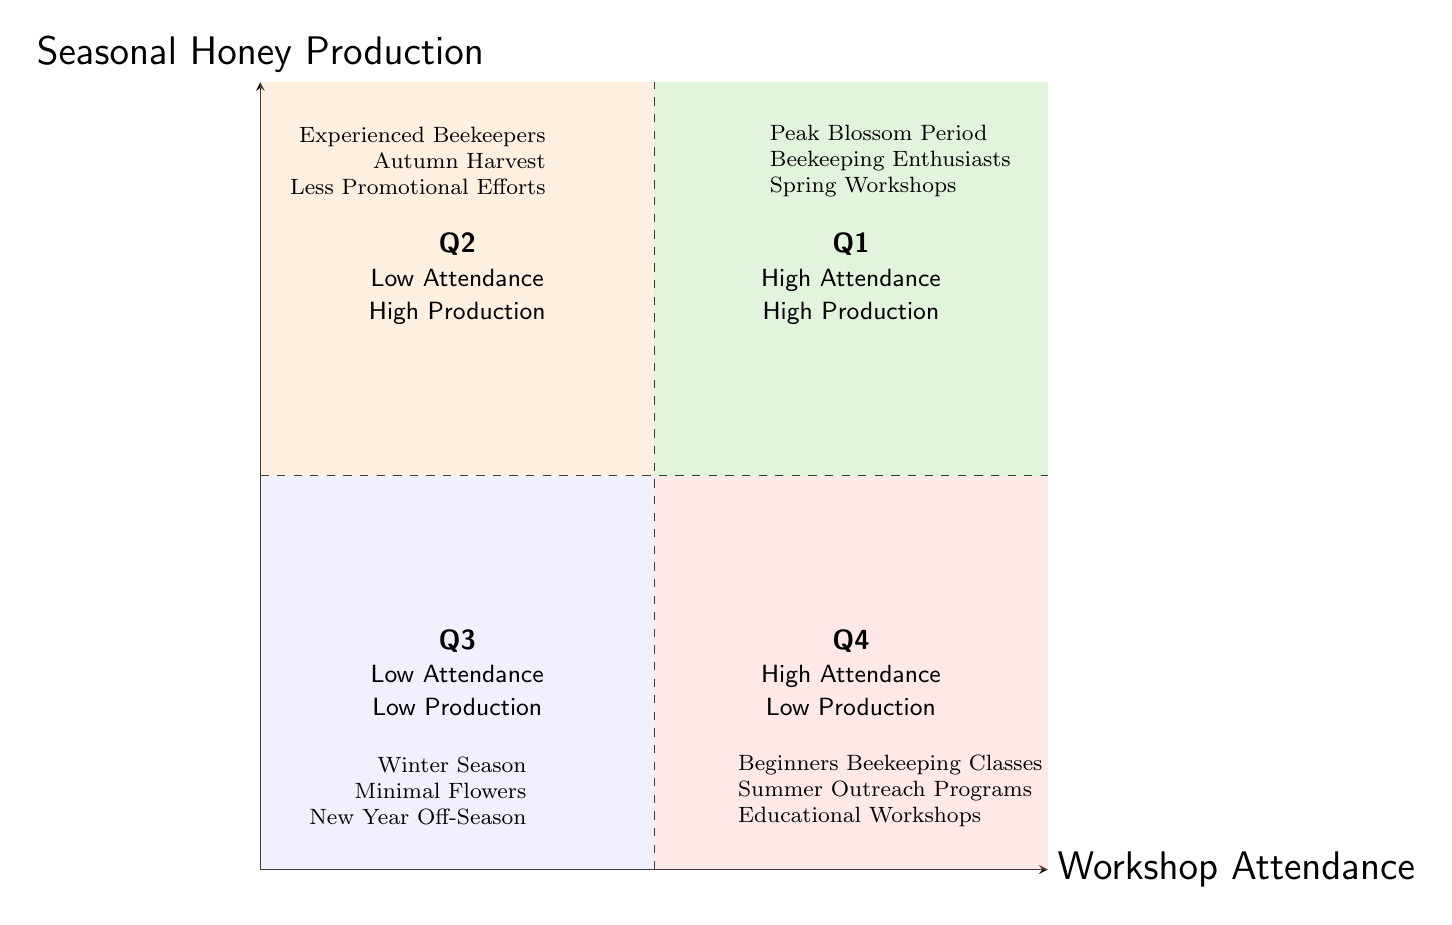What are the examples under Q1? Q1 has examples listed as "Peak Blossom Period," "Beekeeping Enthusiasts," and "Spring Workshops," which are located in the quadrant representing High Attendance and High Production.
Answer: Peak Blossom Period, Beekeeping Enthusiasts, Spring Workshops What quadrant represents High Attendance and Low Production? The quadrant that represents High Attendance and Low Production is Q4, located at the bottom right of the diagram, with a description saying "High Attendance, Low Production."
Answer: Q4 How many quadrants are shown in the diagram? The diagram displays a total of four quadrants, each representing a different combination of Workshop Attendance and Seasonal Honey Production.
Answer: Four Which quadrant includes the examples of experienced beekeepers? The examples of experienced beekeepers are found in Q2, which describes sessions where there is Low Attendance but High Production.
Answer: Q2 What seasonal period does Q3 represent? Q3 characterizes the Winter Season, which typically aligns with Low Attendance and Low Production due to fewer flowering plants.
Answer: Winter Season What can contribute to high production with low attendance as seen in Q2? Factors like "Less Promotional Efforts" and specific experienced beekeeper workshops can lead to high production with low attendance in this quadrant.
Answer: Less Promotional Efforts Which quadrant is likely to have beginners attending workshops? Beginners are likely to attend workshops found in Q4, indicating High Attendance but Low Production during such learning sessions.
Answer: Q4 What does Q1 indicate about the relationship between attendance and production? Q1 indicates that when both attendance and production are high, it is beneficial, often occurring during peak seasons or for enthusiasts.
Answer: Both high 